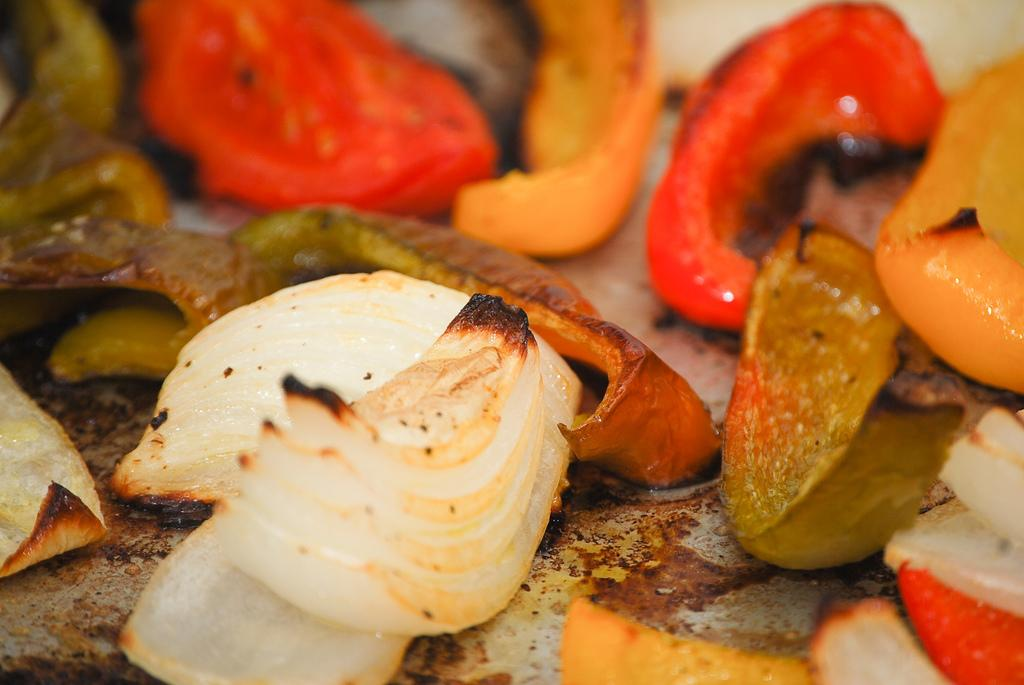What type of vegetables can be seen in the image? There are onions, tomatoes, and capsicums in the image, as well as other cut vegetables. How are the vegetables prepared in the image? The vegetables are fried. What is the background of the image like? The background of the image is blurred. Where is the throne located in the image? There is no throne present in the image. What type of flower can be seen in the image? There are no flowers present in the image. What type of beverage is being served in the image? There is no beverage present in the image. 